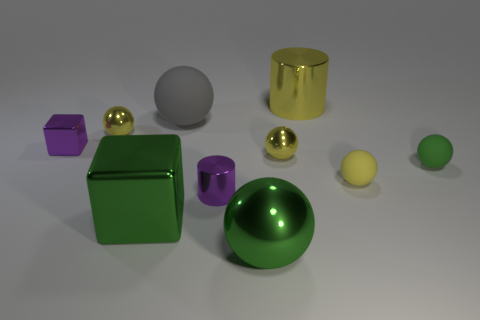What shape is the thing that is both to the left of the green shiny cube and on the right side of the tiny cube?
Offer a terse response. Sphere. There is a big cube that is the same color as the big metallic ball; what is its material?
Provide a short and direct response. Metal. What number of cylinders are red objects or big objects?
Your response must be concise. 1. The shiny cube that is the same color as the tiny shiny cylinder is what size?
Offer a very short reply. Small. Are there fewer tiny yellow objects that are on the left side of the small shiny block than small yellow shiny things?
Your response must be concise. Yes. What color is the matte sphere that is in front of the gray rubber sphere and on the left side of the tiny green ball?
Provide a succinct answer. Yellow. What number of other objects are there of the same shape as the green matte thing?
Make the answer very short. 5. Is the number of small green matte things that are to the right of the green shiny block less than the number of large matte spheres that are in front of the small green matte sphere?
Your answer should be compact. No. Is the material of the big yellow thing the same as the purple cube that is left of the purple cylinder?
Offer a terse response. Yes. Are there any other things that are the same material as the small cylinder?
Keep it short and to the point. Yes. 